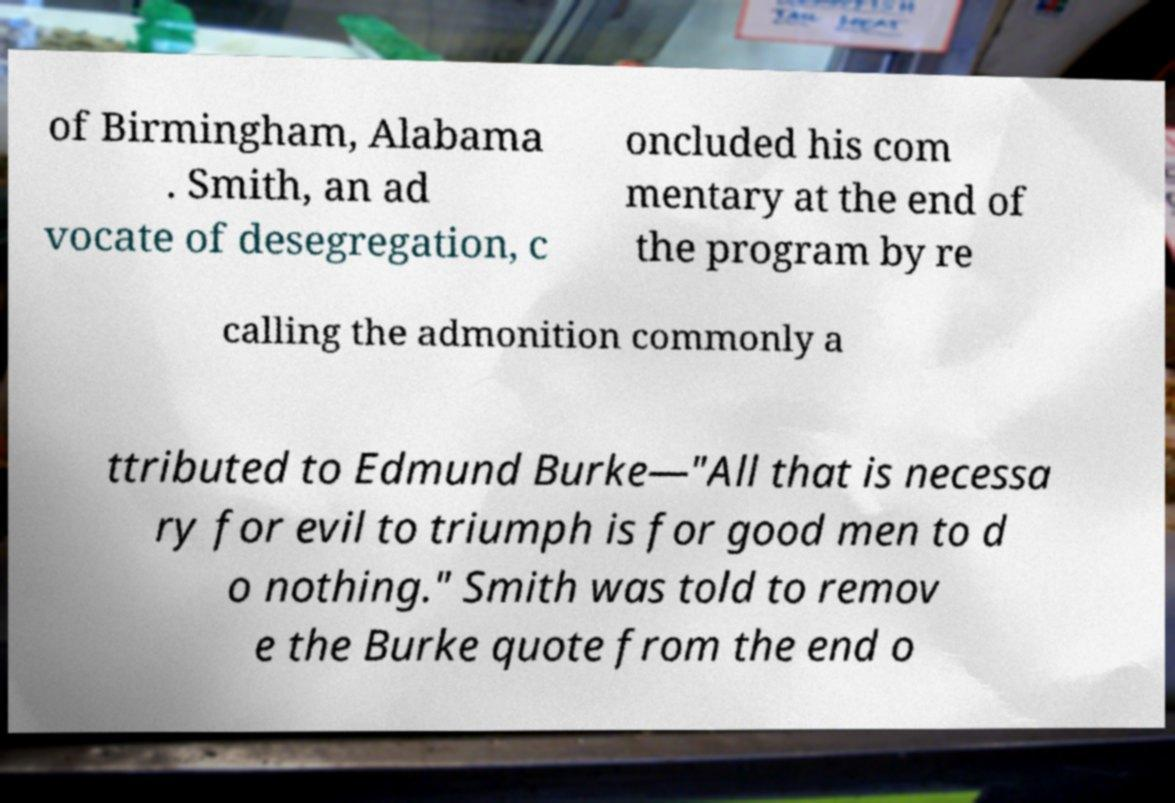I need the written content from this picture converted into text. Can you do that? of Birmingham, Alabama . Smith, an ad vocate of desegregation, c oncluded his com mentary at the end of the program by re calling the admonition commonly a ttributed to Edmund Burke—"All that is necessa ry for evil to triumph is for good men to d o nothing." Smith was told to remov e the Burke quote from the end o 